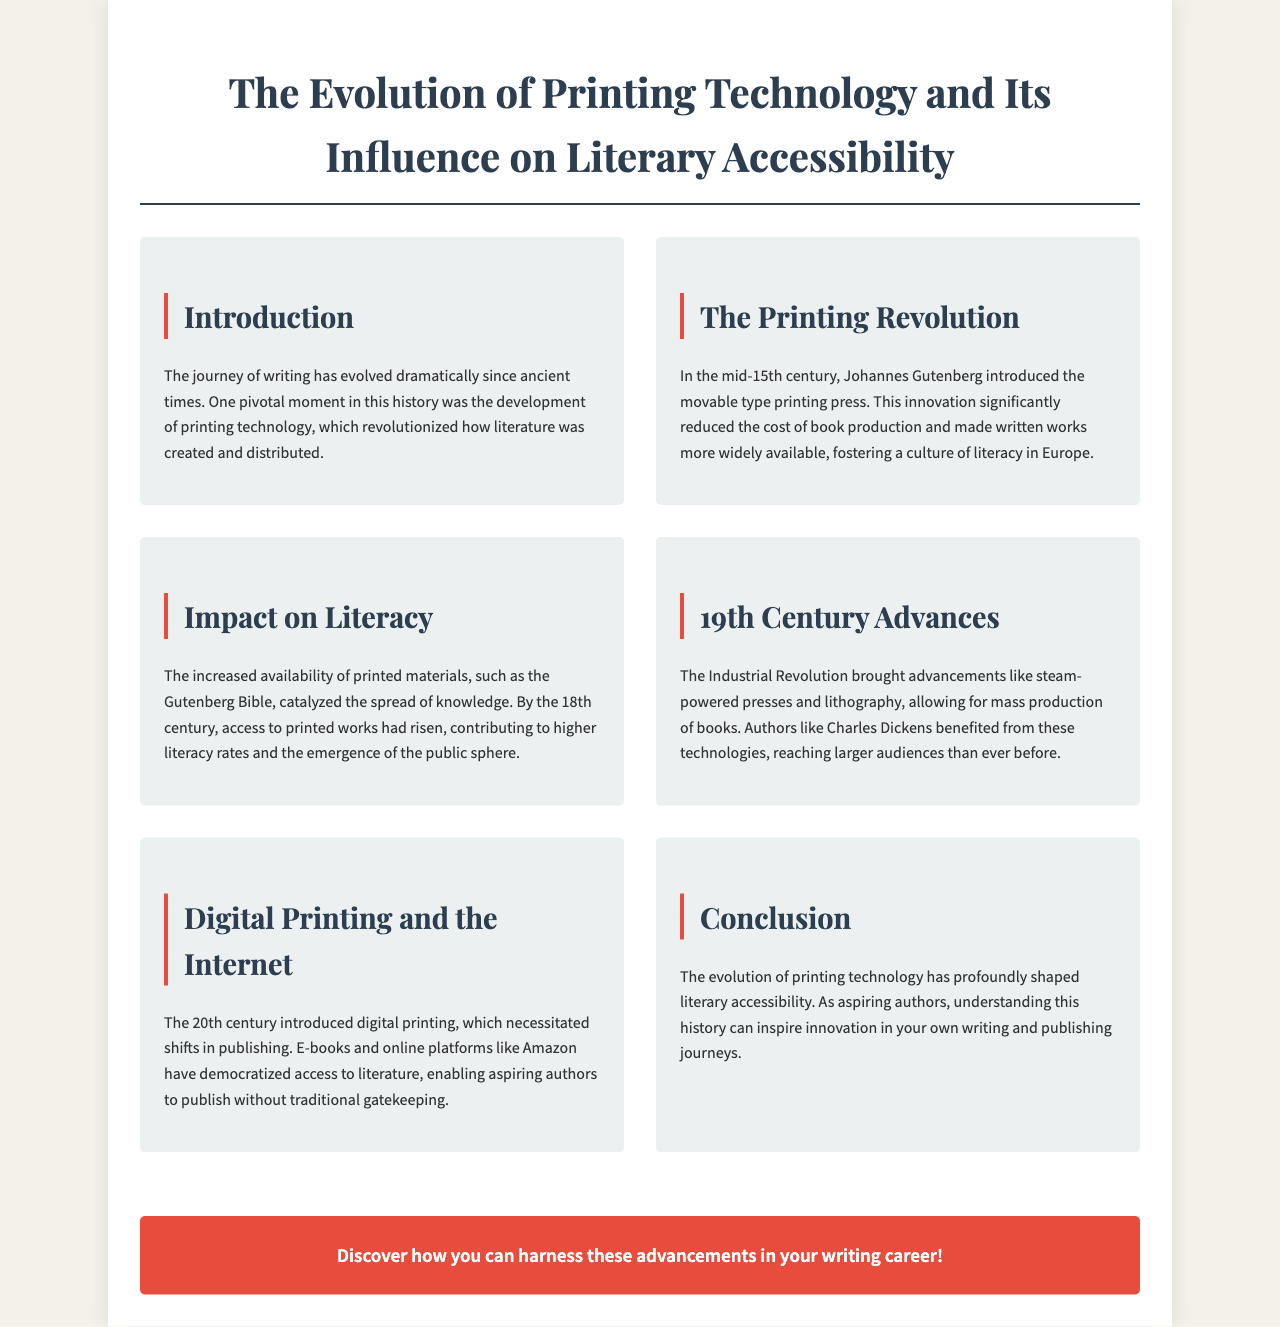What significant invention did Johannes Gutenberg introduce? The document states that Johannes Gutenberg introduced the movable type printing press in the mid-15th century.
Answer: movable type printing press What did the Gutenberg Bible catalyze? The text mentions that the increased availability of printed materials like the Gutenberg Bible catalyzed the spread of knowledge.
Answer: spread of knowledge Which century saw advancements like steam-powered presses? The document specifies that the 19th century brought advancements like steam-powered presses and lithography.
Answer: 19th century What impact did digital printing and the internet have on publishing? According to the document, digital printing and the internet have democratized access to literature.
Answer: democratized access What culture did the printing revolution foster in Europe? The text indicates that the printing revolution fostered a culture of literacy in Europe.
Answer: culture of literacy How has the evolution of printing technology influenced aspiring authors? The conclusion states that understanding the history of printing technology can inspire innovation in the writing and publishing journeys of aspiring authors.
Answer: inspire innovation 